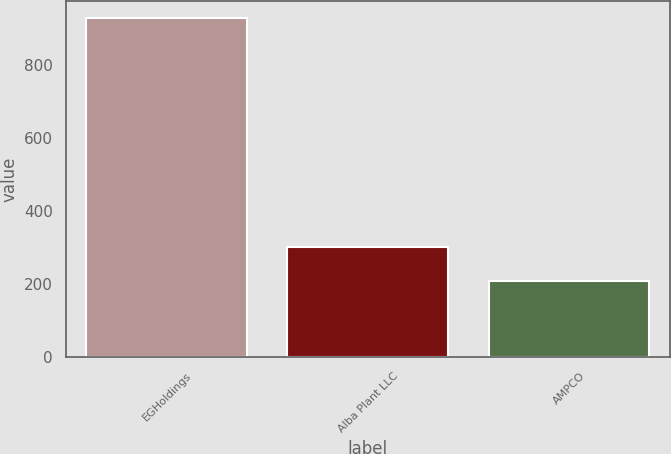Convert chart to OTSL. <chart><loc_0><loc_0><loc_500><loc_500><bar_chart><fcel>EGHoldings<fcel>Alba Plant LLC<fcel>AMPCO<nl><fcel>927<fcel>303<fcel>210<nl></chart> 